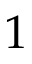Convert formula to latex. <formula><loc_0><loc_0><loc_500><loc_500>1</formula> 